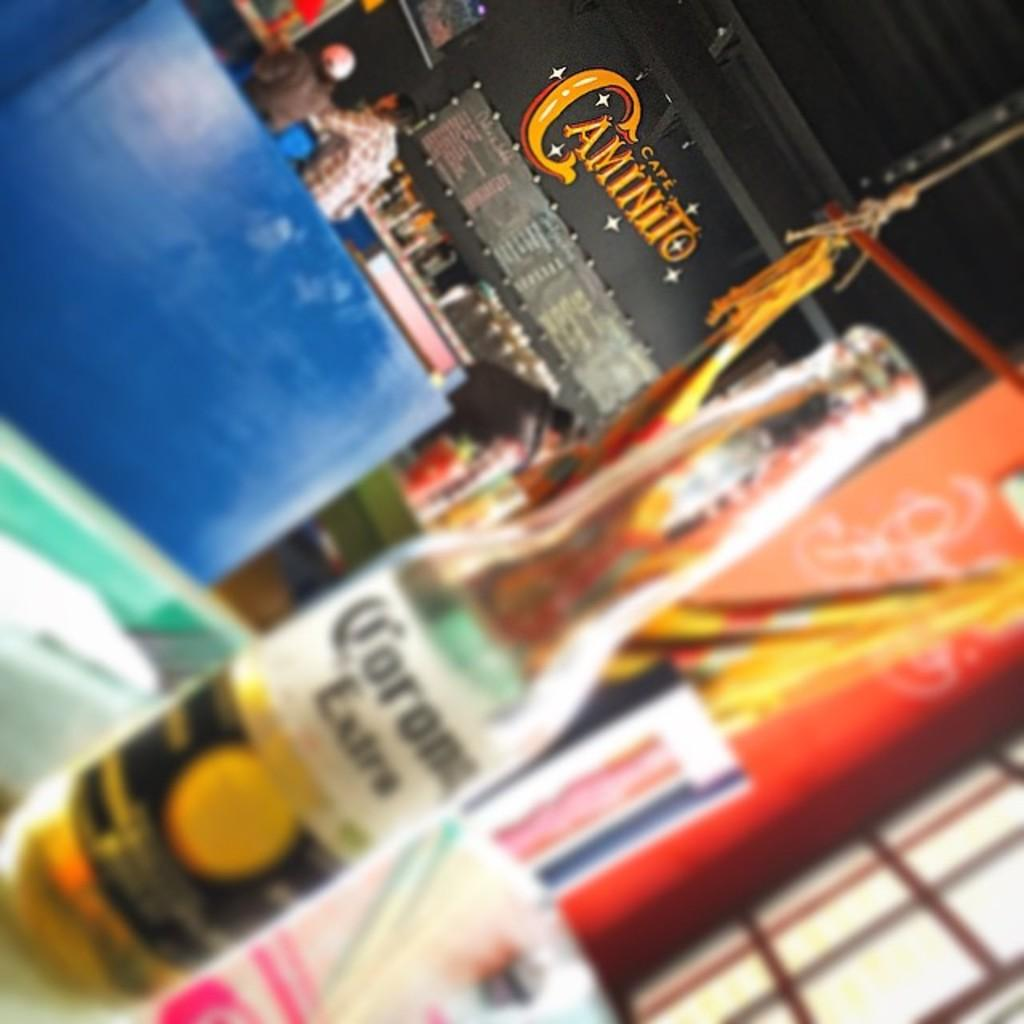Provide a one-sentence caption for the provided image. On a table, a blurred photo of a carona is seen with a Caminito sign in the background. 